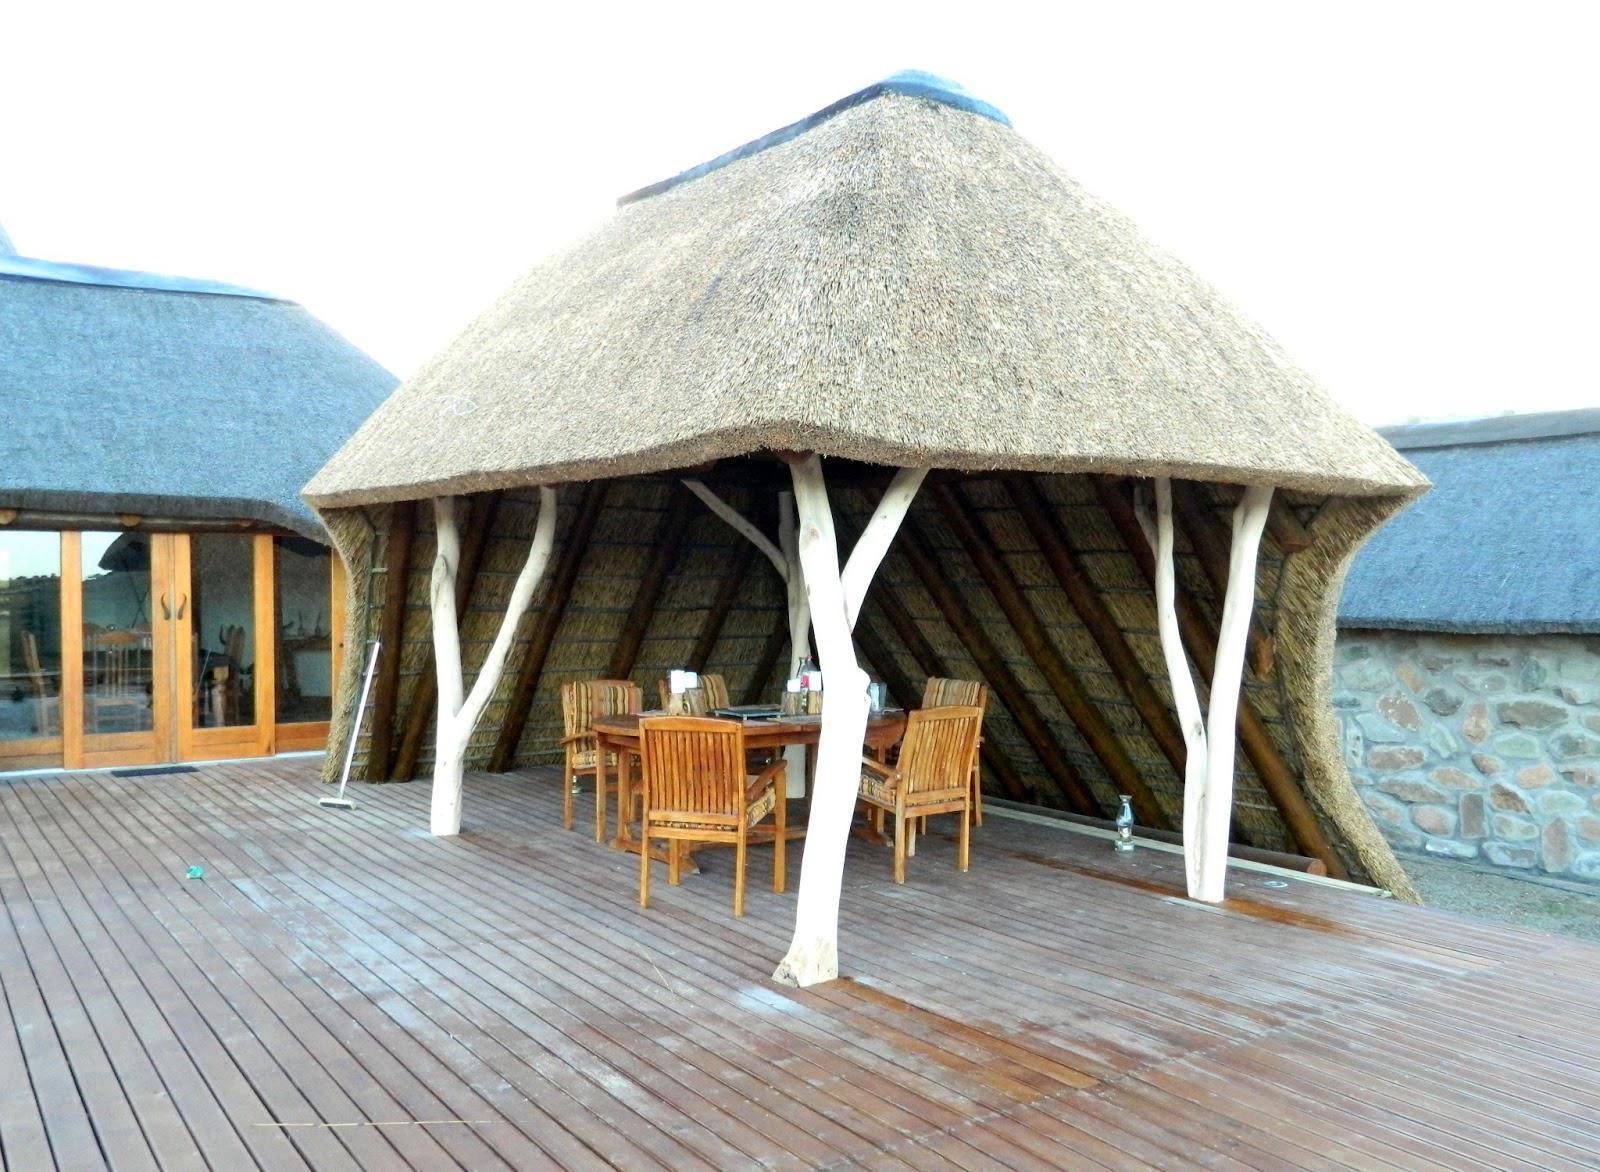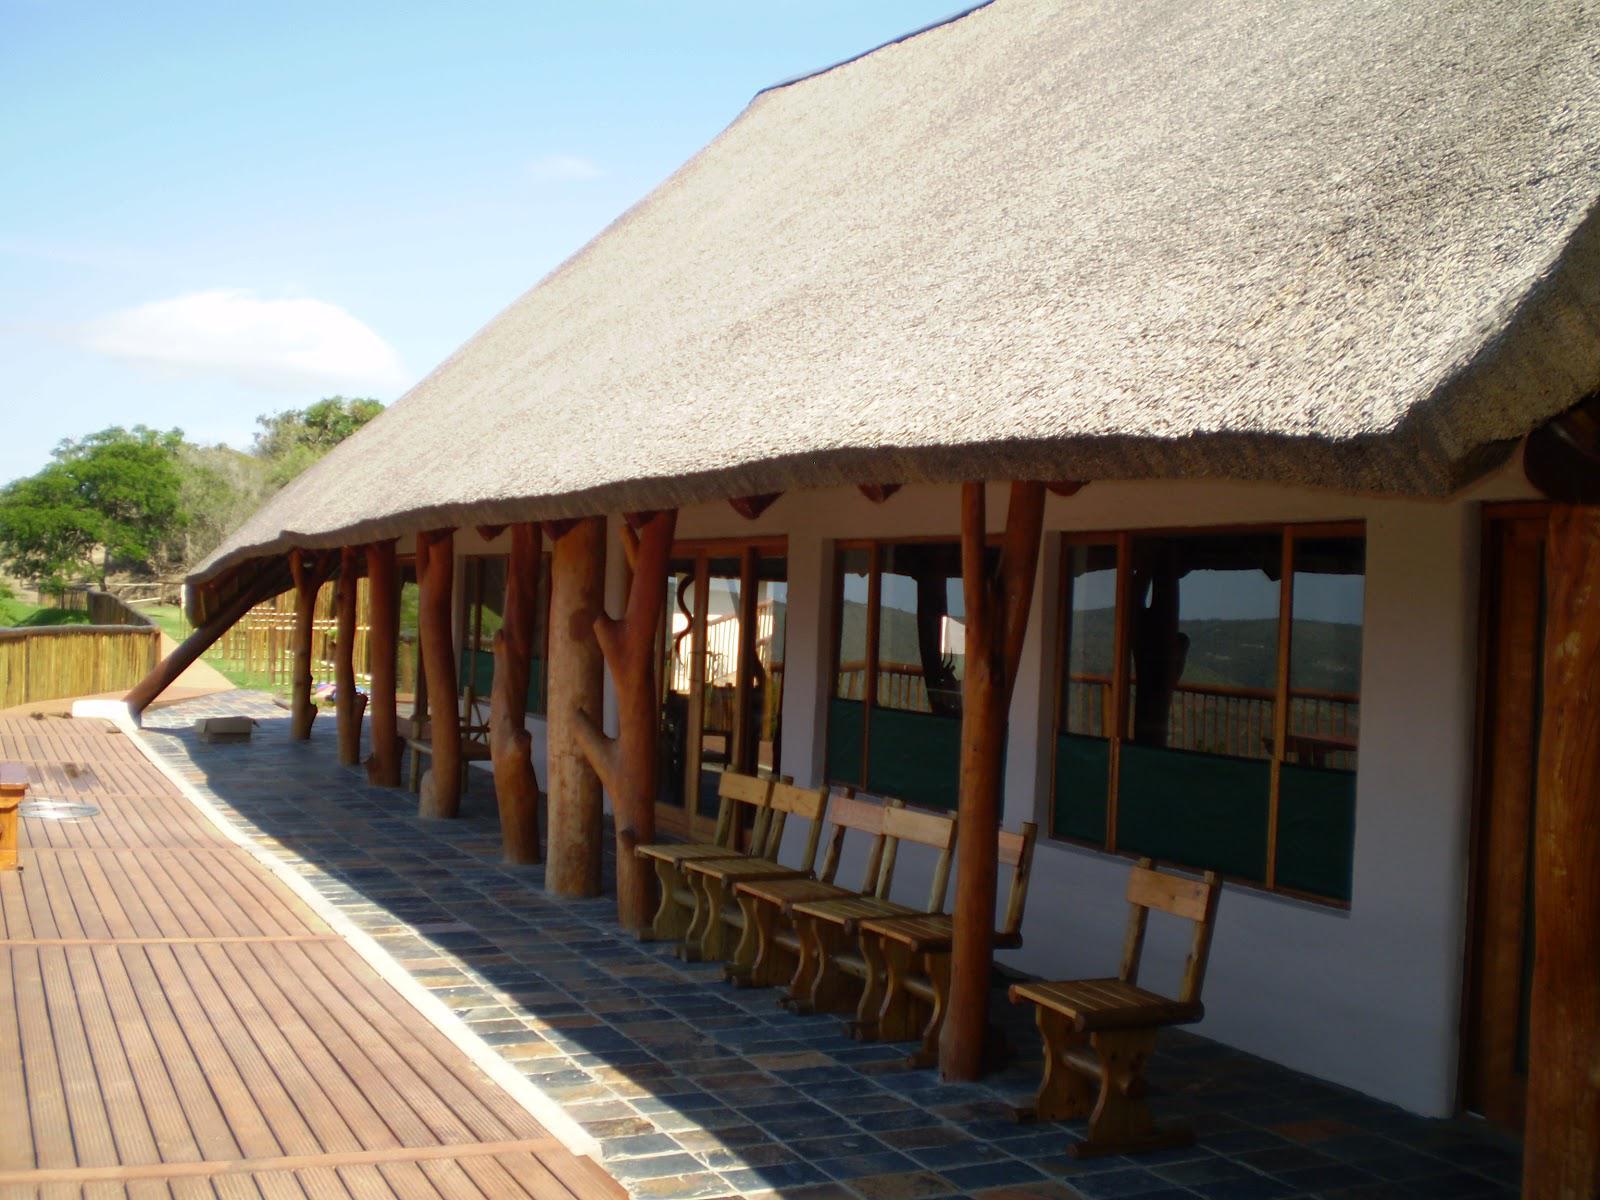The first image is the image on the left, the second image is the image on the right. Examine the images to the left and right. Is the description "In one of the images, you can see a man-made pool just in front of the dwelling." accurate? Answer yes or no. No. The first image is the image on the left, the second image is the image on the right. Examine the images to the left and right. Is the description "There is a pool in one image and not the other." accurate? Answer yes or no. No. 